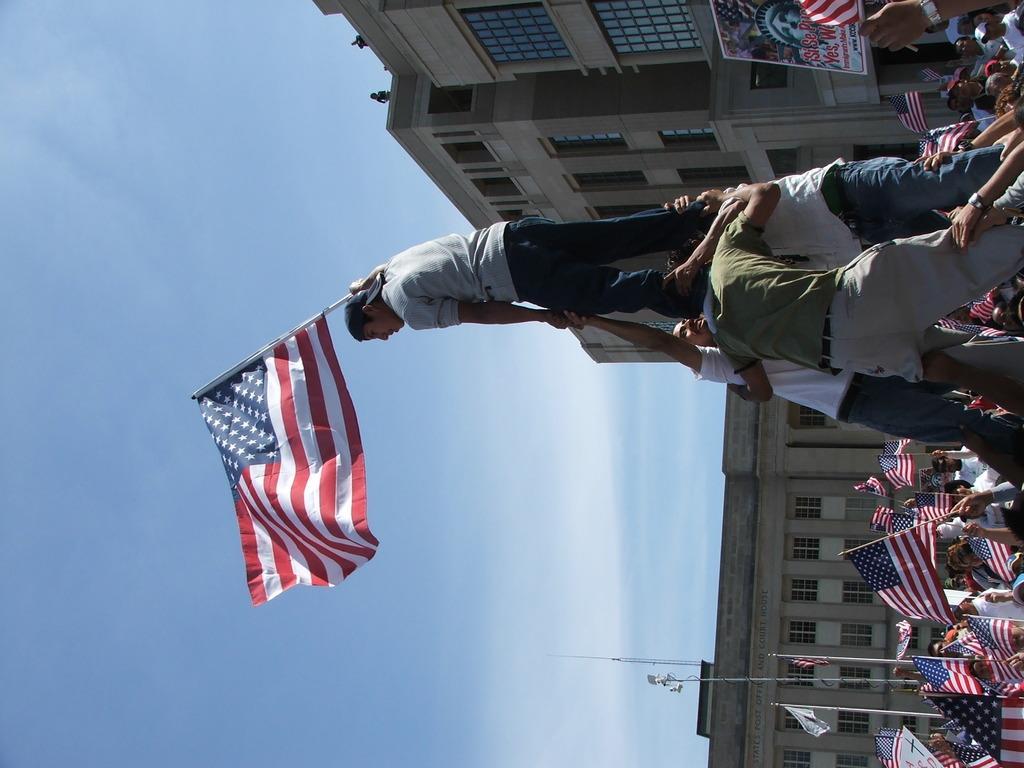In one or two sentences, can you explain what this image depicts? In the center of the image we can see a person standing on the men and holding a flag. In the background we can see persons, flags, poles, building, sky and clouds. 